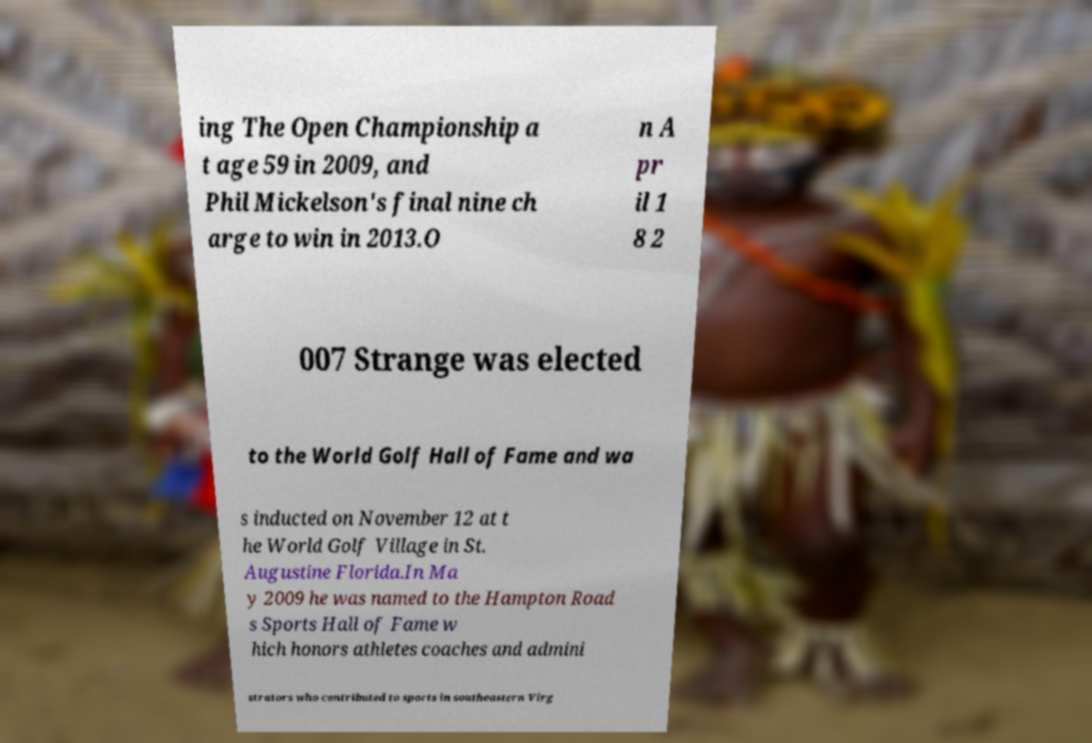I need the written content from this picture converted into text. Can you do that? ing The Open Championship a t age 59 in 2009, and Phil Mickelson's final nine ch arge to win in 2013.O n A pr il 1 8 2 007 Strange was elected to the World Golf Hall of Fame and wa s inducted on November 12 at t he World Golf Village in St. Augustine Florida.In Ma y 2009 he was named to the Hampton Road s Sports Hall of Fame w hich honors athletes coaches and admini strators who contributed to sports in southeastern Virg 